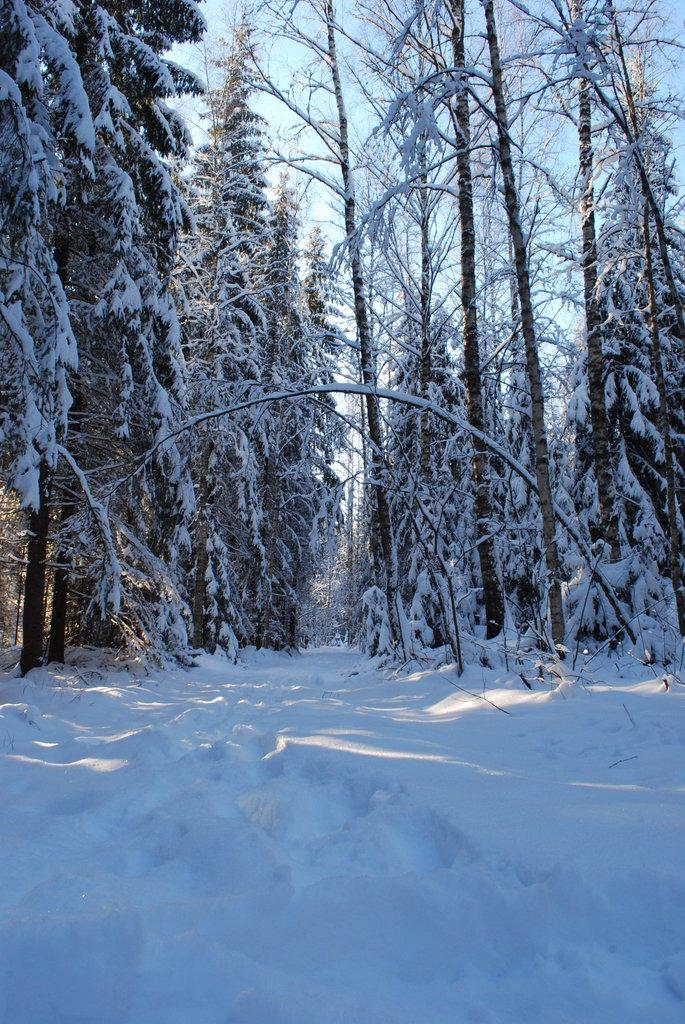What type of weather condition is depicted in the image? There is snow on the ground in the image, indicating a snowy weather condition. What natural elements can be seen in the image? There are trees in the image, and snow is present on the trees. What is visible at the top of the image? The sky is visible at the top of the image. Can you see any cracks in the ground caused by the earthquake in the image? There is no earthquake or cracks in the ground present in the image; it depicts a snowy scene with trees and snow on the trees. 